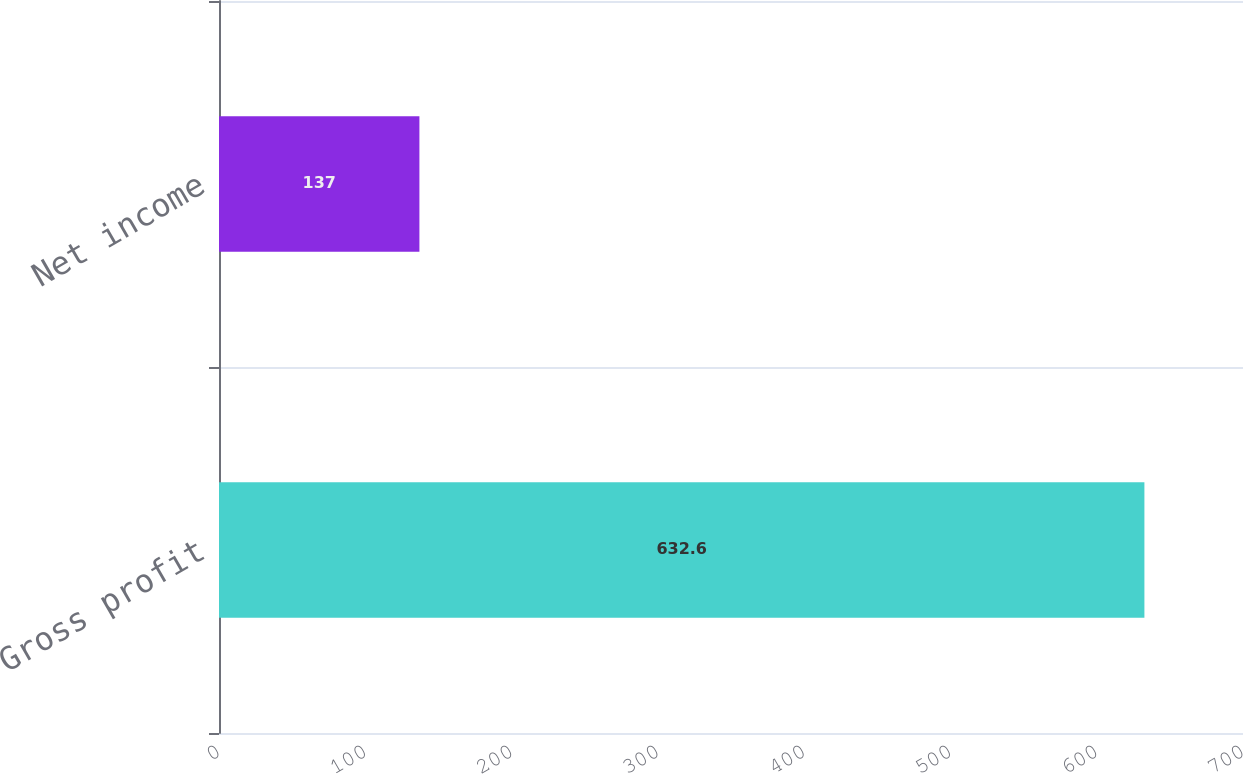<chart> <loc_0><loc_0><loc_500><loc_500><bar_chart><fcel>Gross profit<fcel>Net income<nl><fcel>632.6<fcel>137<nl></chart> 